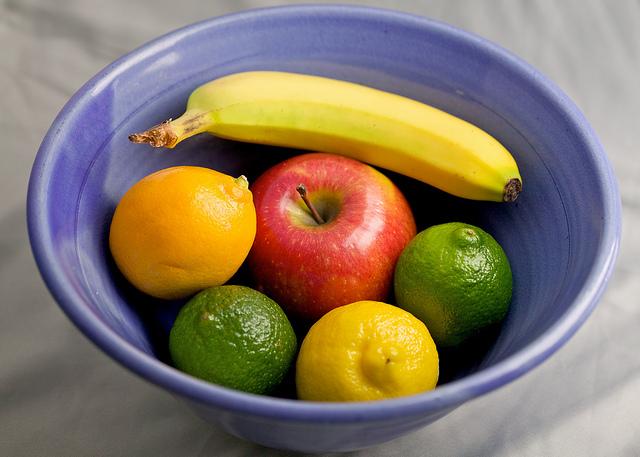What color is the bowl?
Quick response, please. Blue. What color is the bowl the fruit is in?
Concise answer only. Blue. What is the color of the container?
Give a very brief answer. Blue. Is there a banana in the picture?
Short answer required. Yes. How many limes are there?
Concise answer only. 2. How many limes?
Quick response, please. 2. What face does the topmost fruit have?
Answer briefly. None. Is this food sugary?
Write a very short answer. No. What is the bowl made of?
Keep it brief. Ceramic. Is the bowl plastic or glass?
Short answer required. Glass. How many big limes?
Give a very brief answer. 2. 